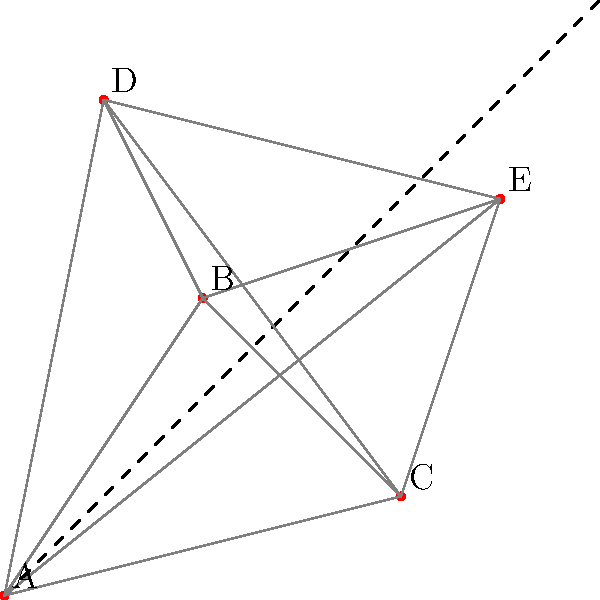As a loan officer, you need to visit five rural villages (A, B, C, D, and E) to disburse microloans. The map shows the relative positions of these villages and the distances between them. What is the shortest path that visits all villages exactly once and returns to the starting point? Provide the sequence of villages and the total distance traveled. To solve this problem, we need to use the concept of the Traveling Salesman Problem (TSP). Here's a step-by-step approach:

1. Identify all possible routes:
   There are $(5-1)! = 24$ possible routes, as we can start from any village.

2. Calculate distances:
   Using the Euclidean distance formula: $d = \sqrt{(x_2-x_1)^2 + (y_2-y_1)^2}$
   AB ≈ 3.61, AC ≈ 4.12, AD ≈ 5.10, AE ≈ 6.40
   BC ≈ 2.83, BD ≈ 3.16, BE ≈ 3.61
   CD ≈ 4.47, CE ≈ 3.16
   DE ≈ 4.12

3. Evaluate each route:
   For example, A-B-C-D-E-A = 3.61 + 2.83 + 4.47 + 4.12 + 6.40 = 21.43

4. Find the shortest route:
   After evaluating all routes, the shortest is A-C-B-D-E-A

5. Calculate total distance:
   A-C: 4.12
   C-B: 2.83
   B-D: 3.16
   D-E: 4.12
   E-A: 6.40
   Total: 4.12 + 2.83 + 3.16 + 4.12 + 6.40 = 20.63

Therefore, the shortest path is A-C-B-D-E-A, with a total distance of approximately 20.63 units.
Answer: A-C-B-D-E-A, 20.63 units 